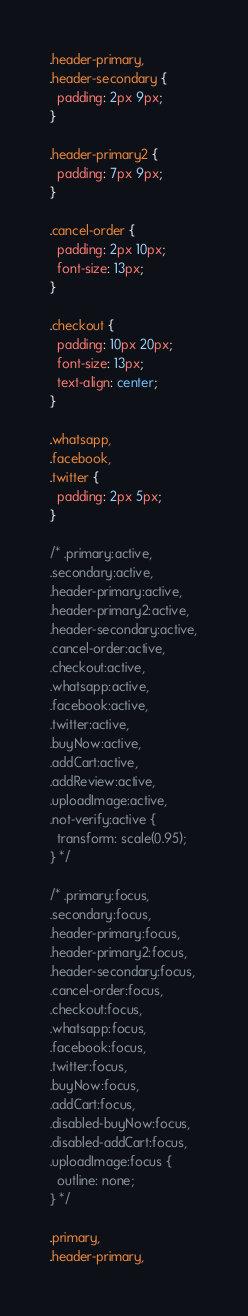Convert code to text. <code><loc_0><loc_0><loc_500><loc_500><_CSS_>.header-primary,
.header-secondary {
  padding: 2px 9px;
}

.header-primary2 {
  padding: 7px 9px;
}

.cancel-order {
  padding: 2px 10px;
  font-size: 13px;
}

.checkout {
  padding: 10px 20px;
  font-size: 13px;
  text-align: center;
}

.whatsapp,
.facebook,
.twitter {
  padding: 2px 5px;
}

/* .primary:active,
.secondary:active,
.header-primary:active,
.header-primary2:active,
.header-secondary:active,
.cancel-order:active,
.checkout:active,
.whatsapp:active,
.facebook:active,
.twitter:active,
.buyNow:active,
.addCart:active,
.addReview:active,
.uploadImage:active,
.not-verify:active {
  transform: scale(0.95);
} */

/* .primary:focus,
.secondary:focus,
.header-primary:focus,
.header-primary2:focus,
.header-secondary:focus,
.cancel-order:focus,
.checkout:focus,
.whatsapp:focus,
.facebook:focus,
.twitter:focus,
.buyNow:focus,
.addCart:focus,
.disabled-buyNow:focus,
.disabled-addCart:focus,
.uploadImage:focus {
  outline: none;
} */

.primary,
.header-primary,</code> 